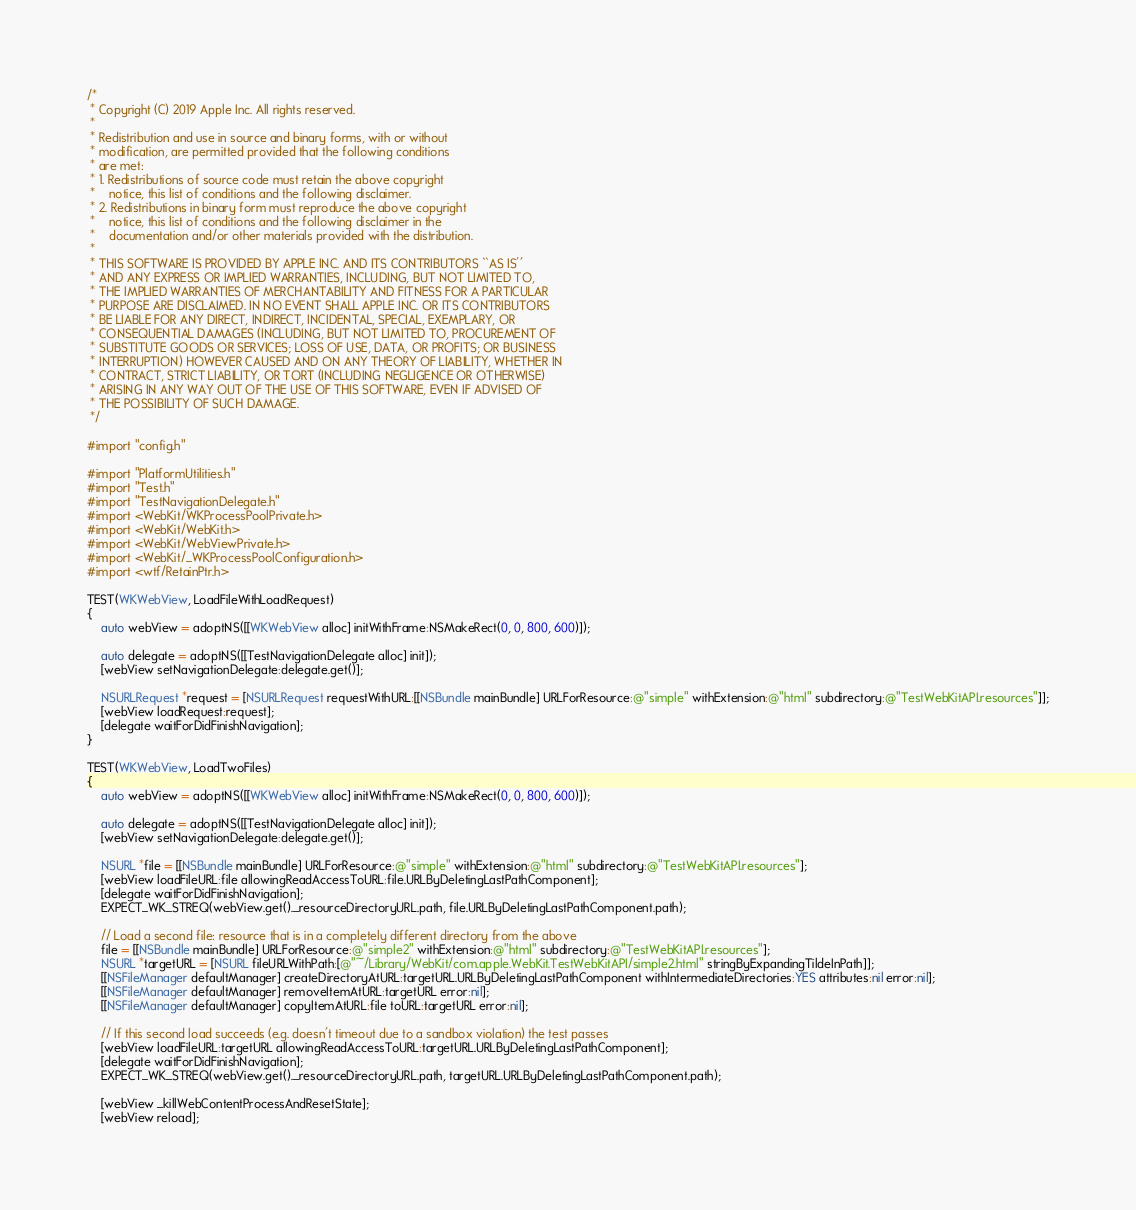Convert code to text. <code><loc_0><loc_0><loc_500><loc_500><_ObjectiveC_>/*
 * Copyright (C) 2019 Apple Inc. All rights reserved.
 *
 * Redistribution and use in source and binary forms, with or without
 * modification, are permitted provided that the following conditions
 * are met:
 * 1. Redistributions of source code must retain the above copyright
 *    notice, this list of conditions and the following disclaimer.
 * 2. Redistributions in binary form must reproduce the above copyright
 *    notice, this list of conditions and the following disclaimer in the
 *    documentation and/or other materials provided with the distribution.
 *
 * THIS SOFTWARE IS PROVIDED BY APPLE INC. AND ITS CONTRIBUTORS ``AS IS''
 * AND ANY EXPRESS OR IMPLIED WARRANTIES, INCLUDING, BUT NOT LIMITED TO,
 * THE IMPLIED WARRANTIES OF MERCHANTABILITY AND FITNESS FOR A PARTICULAR
 * PURPOSE ARE DISCLAIMED. IN NO EVENT SHALL APPLE INC. OR ITS CONTRIBUTORS
 * BE LIABLE FOR ANY DIRECT, INDIRECT, INCIDENTAL, SPECIAL, EXEMPLARY, OR
 * CONSEQUENTIAL DAMAGES (INCLUDING, BUT NOT LIMITED TO, PROCUREMENT OF
 * SUBSTITUTE GOODS OR SERVICES; LOSS OF USE, DATA, OR PROFITS; OR BUSINESS
 * INTERRUPTION) HOWEVER CAUSED AND ON ANY THEORY OF LIABILITY, WHETHER IN
 * CONTRACT, STRICT LIABILITY, OR TORT (INCLUDING NEGLIGENCE OR OTHERWISE)
 * ARISING IN ANY WAY OUT OF THE USE OF THIS SOFTWARE, EVEN IF ADVISED OF
 * THE POSSIBILITY OF SUCH DAMAGE.
 */

#import "config.h"

#import "PlatformUtilities.h"
#import "Test.h"
#import "TestNavigationDelegate.h"
#import <WebKit/WKProcessPoolPrivate.h>
#import <WebKit/WebKit.h>
#import <WebKit/WebViewPrivate.h>
#import <WebKit/_WKProcessPoolConfiguration.h>
#import <wtf/RetainPtr.h>

TEST(WKWebView, LoadFileWithLoadRequest)
{
    auto webView = adoptNS([[WKWebView alloc] initWithFrame:NSMakeRect(0, 0, 800, 600)]);

    auto delegate = adoptNS([[TestNavigationDelegate alloc] init]);
    [webView setNavigationDelegate:delegate.get()];

    NSURLRequest *request = [NSURLRequest requestWithURL:[[NSBundle mainBundle] URLForResource:@"simple" withExtension:@"html" subdirectory:@"TestWebKitAPI.resources"]];
    [webView loadRequest:request];
    [delegate waitForDidFinishNavigation];
}

TEST(WKWebView, LoadTwoFiles)
{
    auto webView = adoptNS([[WKWebView alloc] initWithFrame:NSMakeRect(0, 0, 800, 600)]);

    auto delegate = adoptNS([[TestNavigationDelegate alloc] init]);
    [webView setNavigationDelegate:delegate.get()];

    NSURL *file = [[NSBundle mainBundle] URLForResource:@"simple" withExtension:@"html" subdirectory:@"TestWebKitAPI.resources"];
    [webView loadFileURL:file allowingReadAccessToURL:file.URLByDeletingLastPathComponent];
    [delegate waitForDidFinishNavigation];
    EXPECT_WK_STREQ(webView.get()._resourceDirectoryURL.path, file.URLByDeletingLastPathComponent.path);

    // Load a second file: resource that is in a completely different directory from the above
    file = [[NSBundle mainBundle] URLForResource:@"simple2" withExtension:@"html" subdirectory:@"TestWebKitAPI.resources"];
    NSURL *targetURL = [NSURL fileURLWithPath:[@"~/Library/WebKit/com.apple.WebKit.TestWebKitAPI/simple2.html" stringByExpandingTildeInPath]];
    [[NSFileManager defaultManager] createDirectoryAtURL:targetURL.URLByDeletingLastPathComponent withIntermediateDirectories:YES attributes:nil error:nil];
    [[NSFileManager defaultManager] removeItemAtURL:targetURL error:nil];
    [[NSFileManager defaultManager] copyItemAtURL:file toURL:targetURL error:nil];

    // If this second load succeeds (e.g. doesn't timeout due to a sandbox violation) the test passes
    [webView loadFileURL:targetURL allowingReadAccessToURL:targetURL.URLByDeletingLastPathComponent];
    [delegate waitForDidFinishNavigation];
    EXPECT_WK_STREQ(webView.get()._resourceDirectoryURL.path, targetURL.URLByDeletingLastPathComponent.path);

    [webView _killWebContentProcessAndResetState];
    [webView reload];</code> 